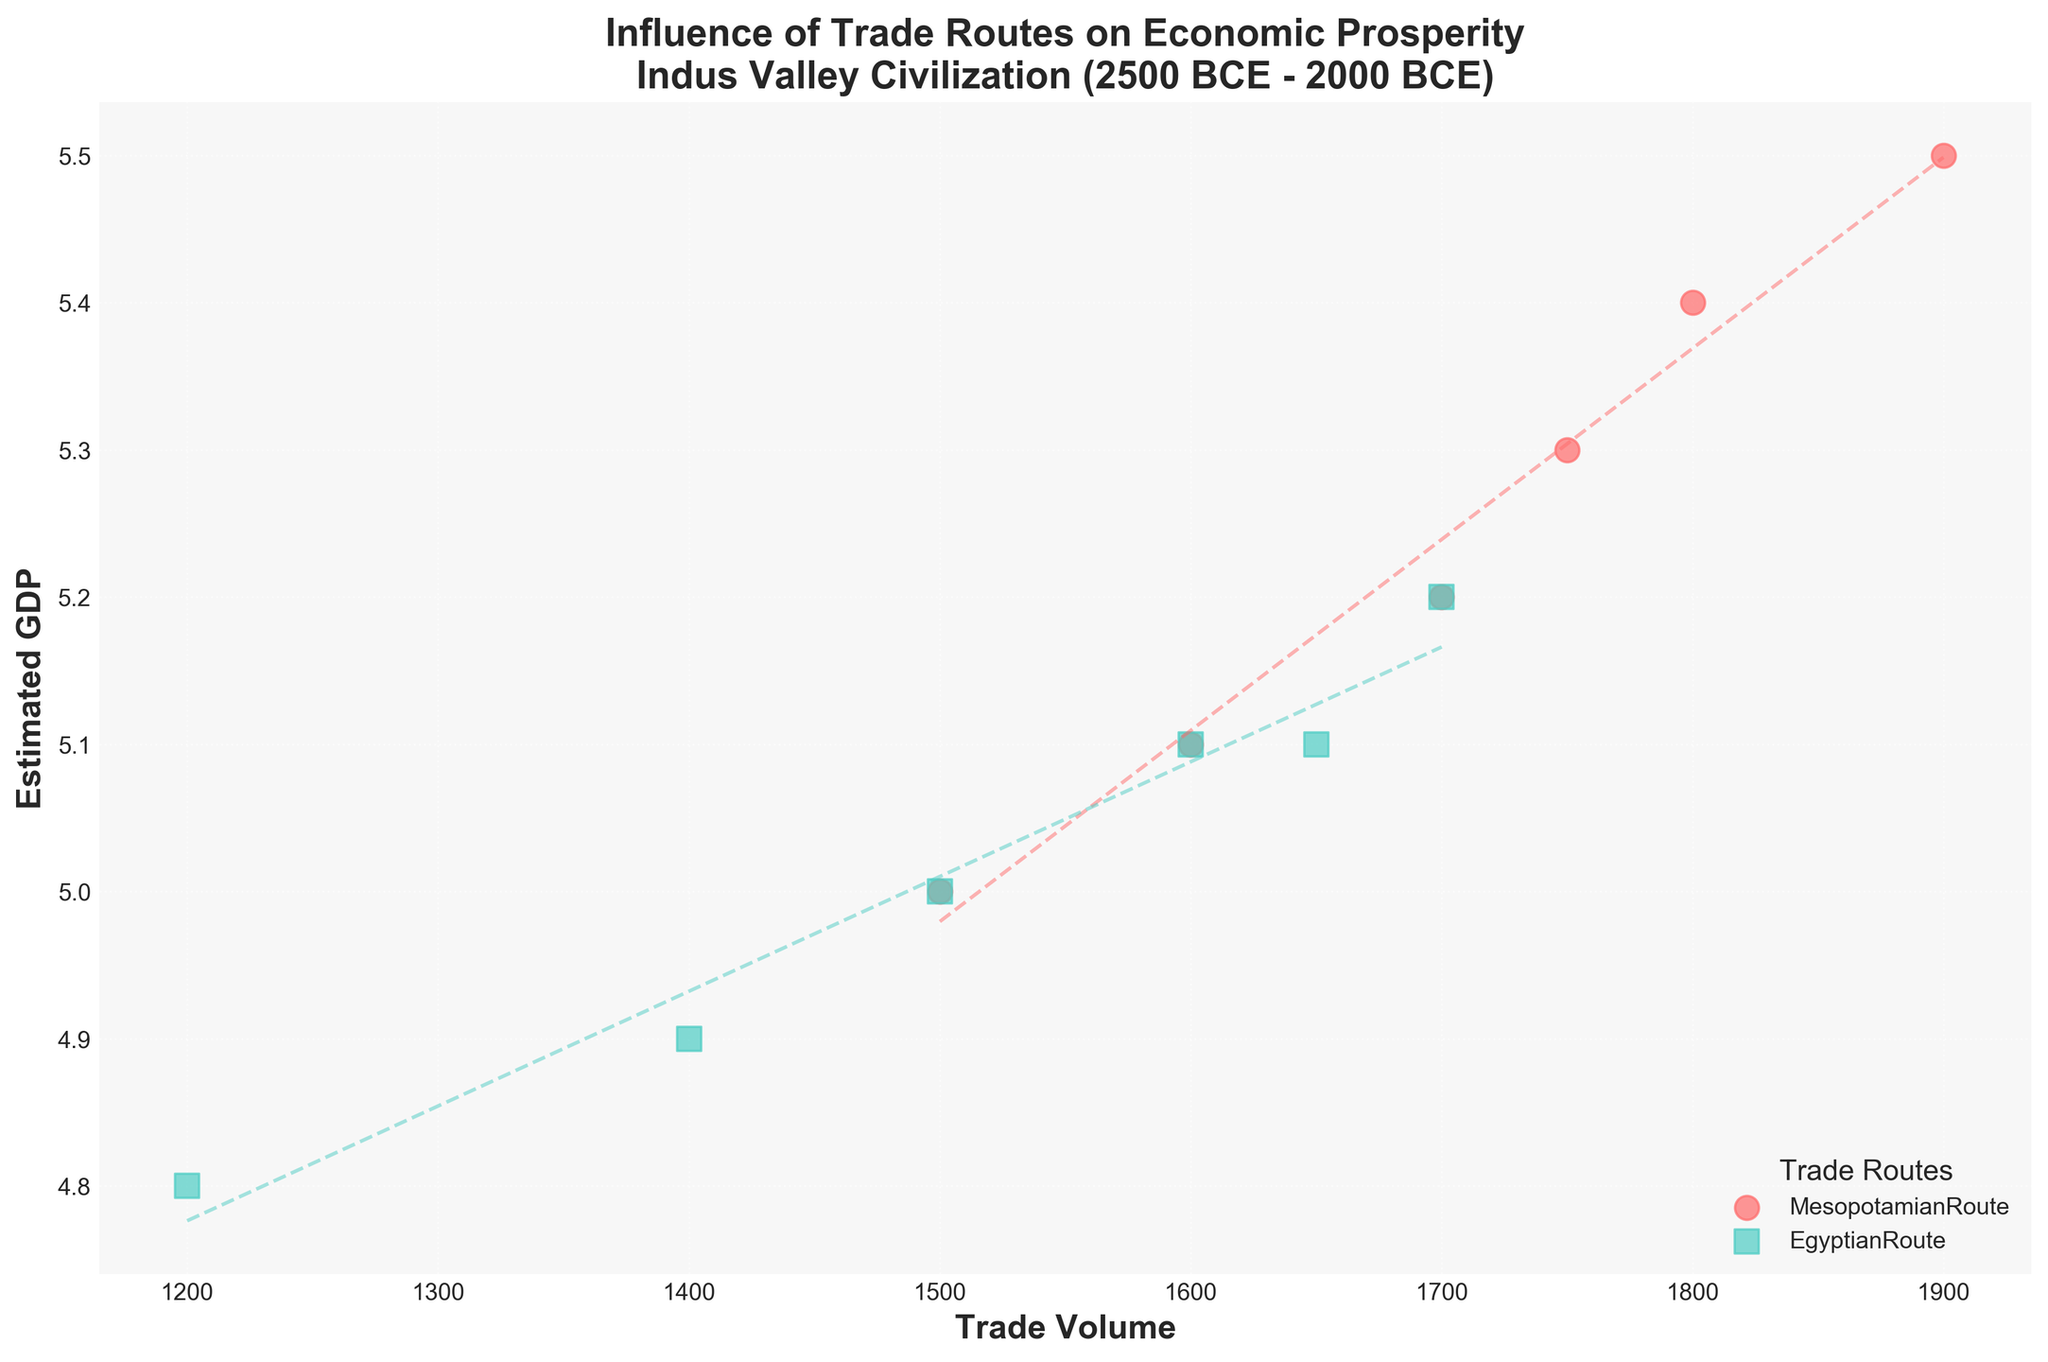what is the title of the plot? The title is usually placed at the top of the figure. In this case, the title reads "Influence of Trade Routes on Economic Prosperity Indus Valley Civilization (2500 BCE - 2000 BCE)."
Answer: Influence of Trade Routes on Economic Prosperity Indus Valley Civilization (2500 BCE - 2000 BCE) How many trade routes are represented in the plot? The legend lists the trade routes, and there are two distinct colors and markers in the scatter plot. The trade routes mentioned are 'MesopotamianRoute' and 'EgyptianRoute'.
Answer: 2 Which trade route showed a higher trade volume overall? By looking at the data points along the x-axis (Trade Volume), the 'MesopotamianRoute' consistently shows higher values compared to the 'EgyptianRoute'.
Answer: MesopotamianRoute What is the trend of GDP with respect to the trade volume for the Egyptian Route? The trend line for the Egyptian Route (dashed line in the corresponding color) shows an upward slope, indicating that as the trade volume increases, the Estimated GDP also increases.
Answer: Increases Which year had the highest recorded GDP for the Egyptian Route? By looking at the data points for the Egyptian Route and their corresponding y-values (Estimated GDP), the year 2000 BCE has the highest Estimated GDP value.
Answer: 2000 BCE Compare the GDP growth patterns between the two trade routes. By examining the trend lines for both routes, both show positive slopes indicating growth in GDP with increased trade volume, but the slope for the Mesopotamian Route is somewhat steeper suggesting a slightly stronger correlation between trade volume and GDP.
Answer: Both show growth; Mesopotamian Route has a slightly steeper trend What is the GDP range for the Mesopotamian Route according to the plot? The data points for the Mesopotamian Route range from the lowest y-value to the highest y-value on the Estimated GDP axis. This range starts at about 5.0 and goes up to 5.5.
Answer: 5.0 to 5.5 What visual differences are there between data points representing the two trade routes? The data points for each trade route have unique markers and colors. The Mesopotamian Route is shown with circular red markers, while the Egyptian Route is shown with square teal markers.
Answer: Different markers (circular for Mesopotamian, square for Egyptian) and colors (red for Mesopotamian, teal for Egyptian) Which trade route had the most consistent GDP values over the observed period? Observing the scatter plot, the Egyptian Route's data points show less fluctuation in GDP values compared to the Mesopotamian Route. The Egyptian Route's values are more tightly clustered together.
Answer: Egyptian Route 